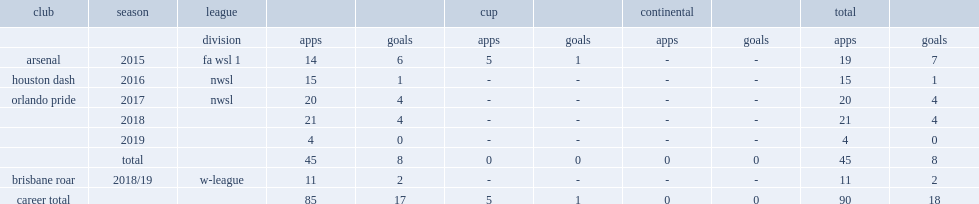Which club did ubogagu play for in 2017? Orlando pride. 